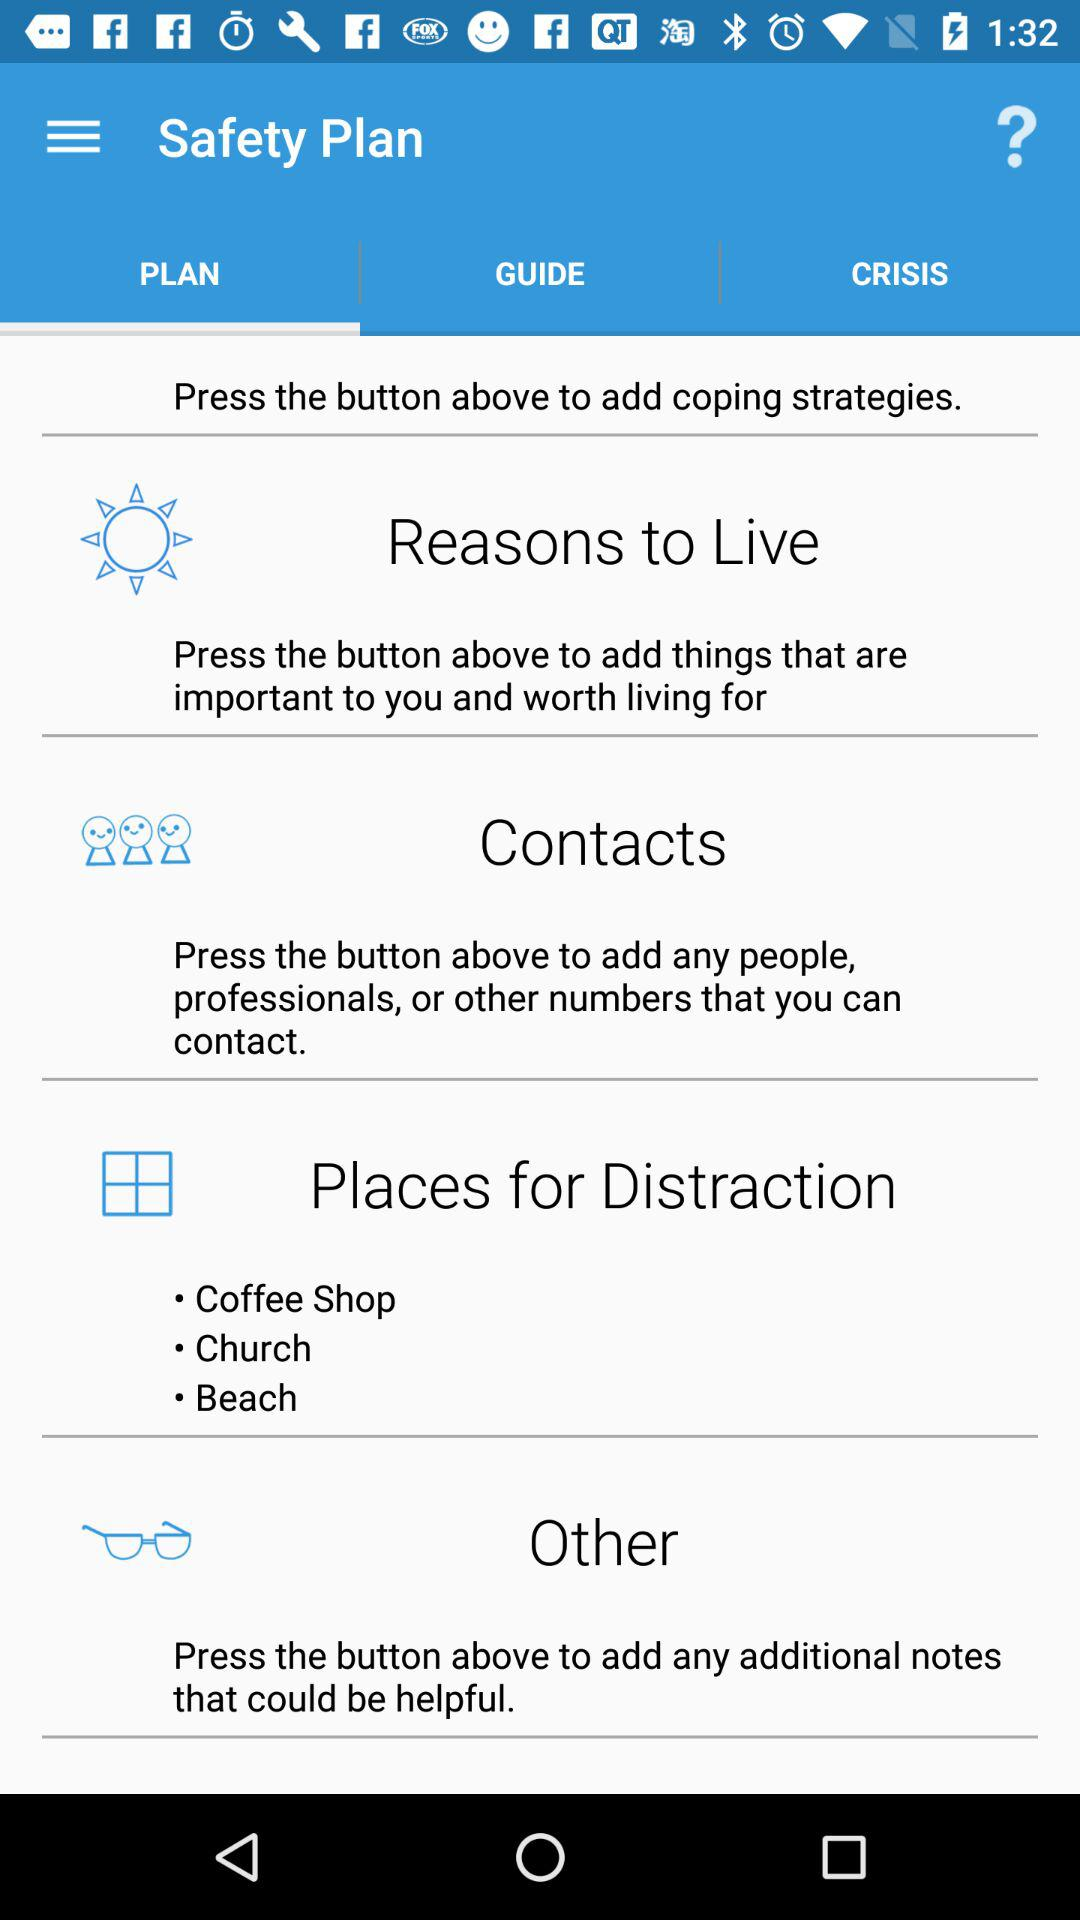What are the available options? The available options are "PLAN", "GUIDE" and "CRISIS". 